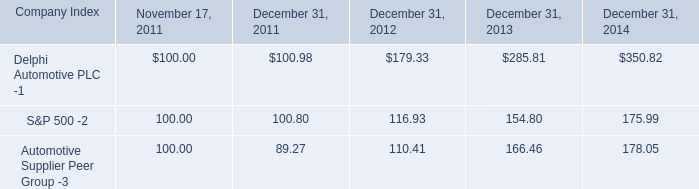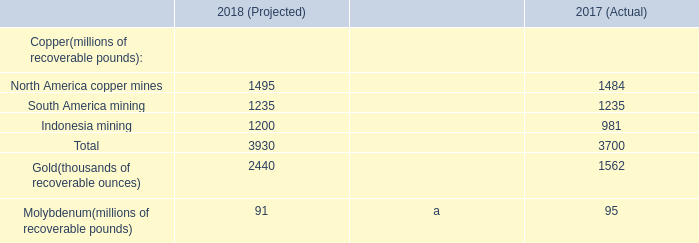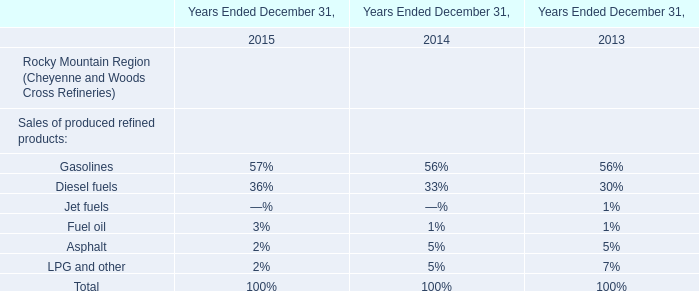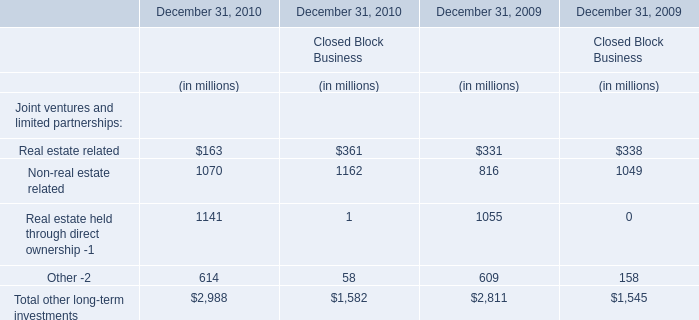What's the sum of all Real estate related that are positive in 2009 and 2010 for Financial Services Businesses 
Computations: (163 + 331)
Answer: 494.0. 